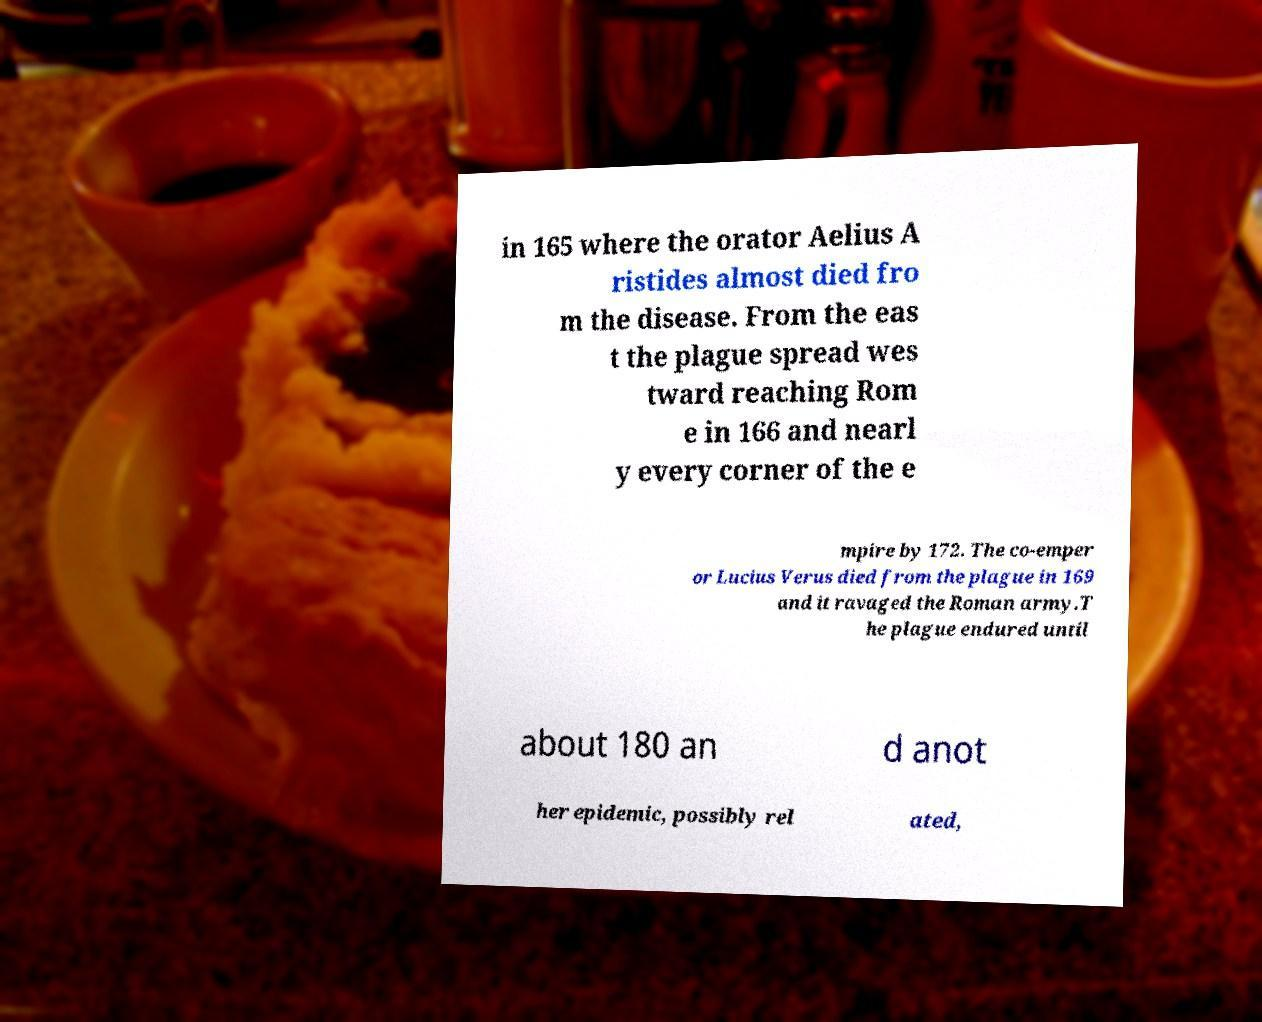I need the written content from this picture converted into text. Can you do that? in 165 where the orator Aelius A ristides almost died fro m the disease. From the eas t the plague spread wes tward reaching Rom e in 166 and nearl y every corner of the e mpire by 172. The co-emper or Lucius Verus died from the plague in 169 and it ravaged the Roman army.T he plague endured until about 180 an d anot her epidemic, possibly rel ated, 